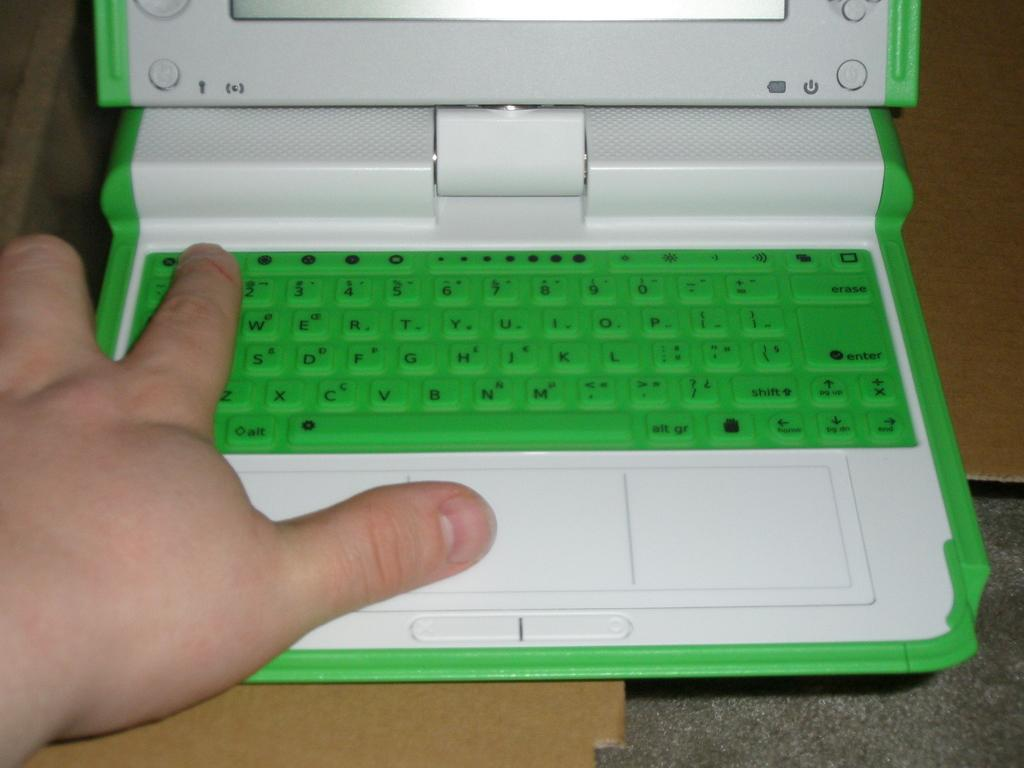<image>
Summarize the visual content of the image. A child sized laptop with a QWERTY keyboard and touchpad. 